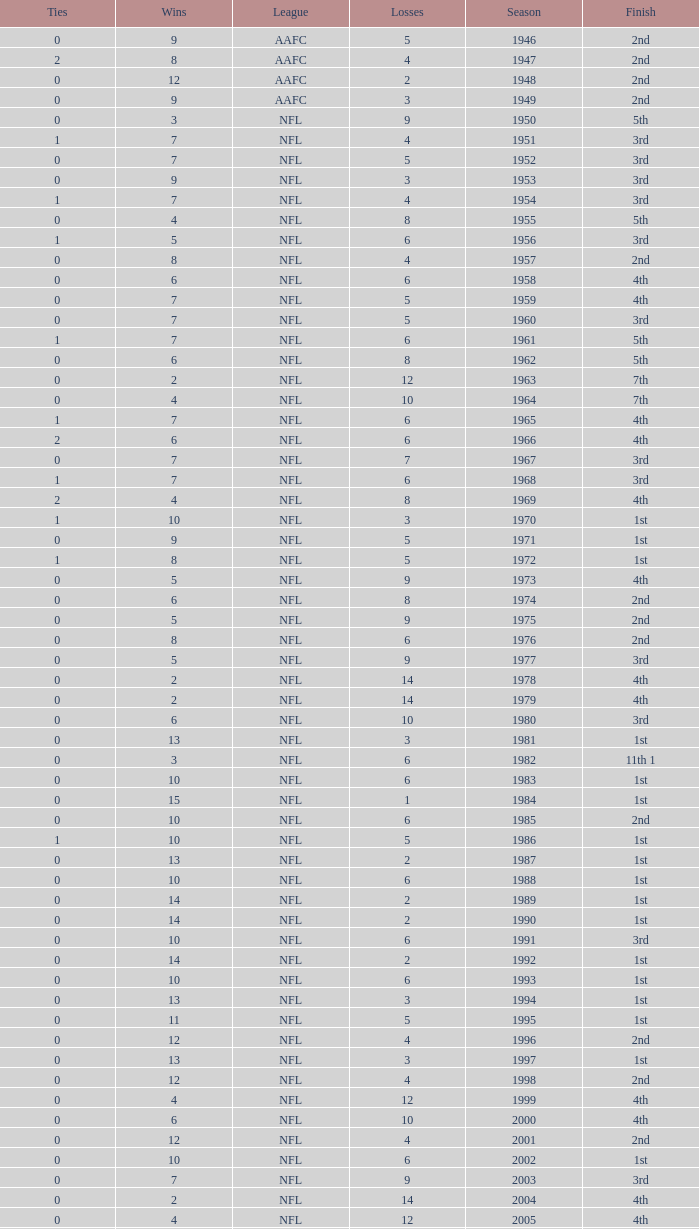What is the losses in the NFL in the 2011 season with less than 13 wins? None. 